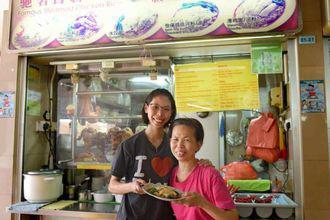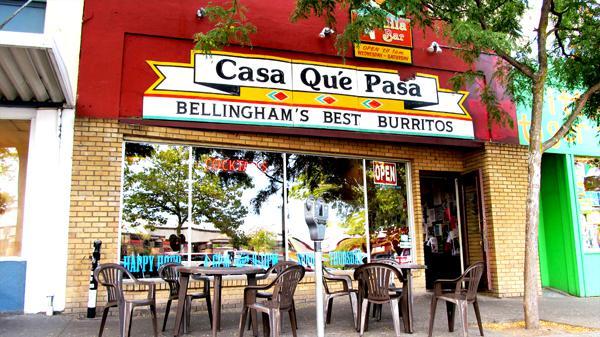The first image is the image on the left, the second image is the image on the right. For the images displayed, is the sentence "Two people are standing in front of a food vendor in the image on the left." factually correct? Answer yes or no. Yes. 